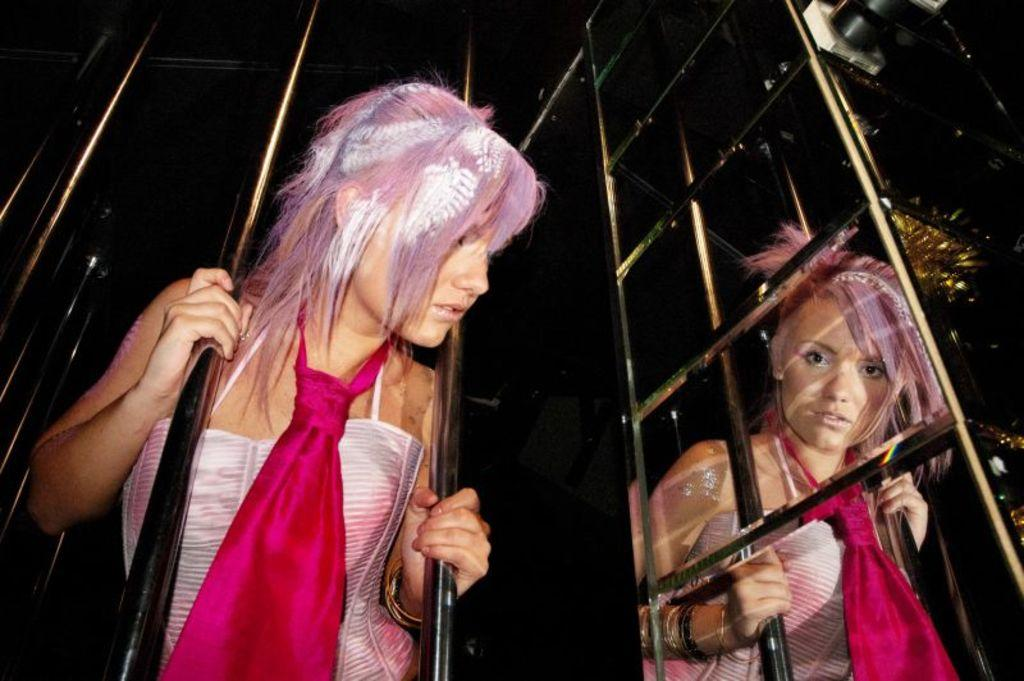What is the position of the first woman in the image? The first woman is visible in between two rods. What is the position of the second woman in the image? The second woman is visible in front of a fence. What can be seen on the right side of the image? Some rods are visible on the right side of the image. What type of pot is being played by the woman in the image? There is no pot or instrument present in the image; the women are not depicted playing any musical instruments. 